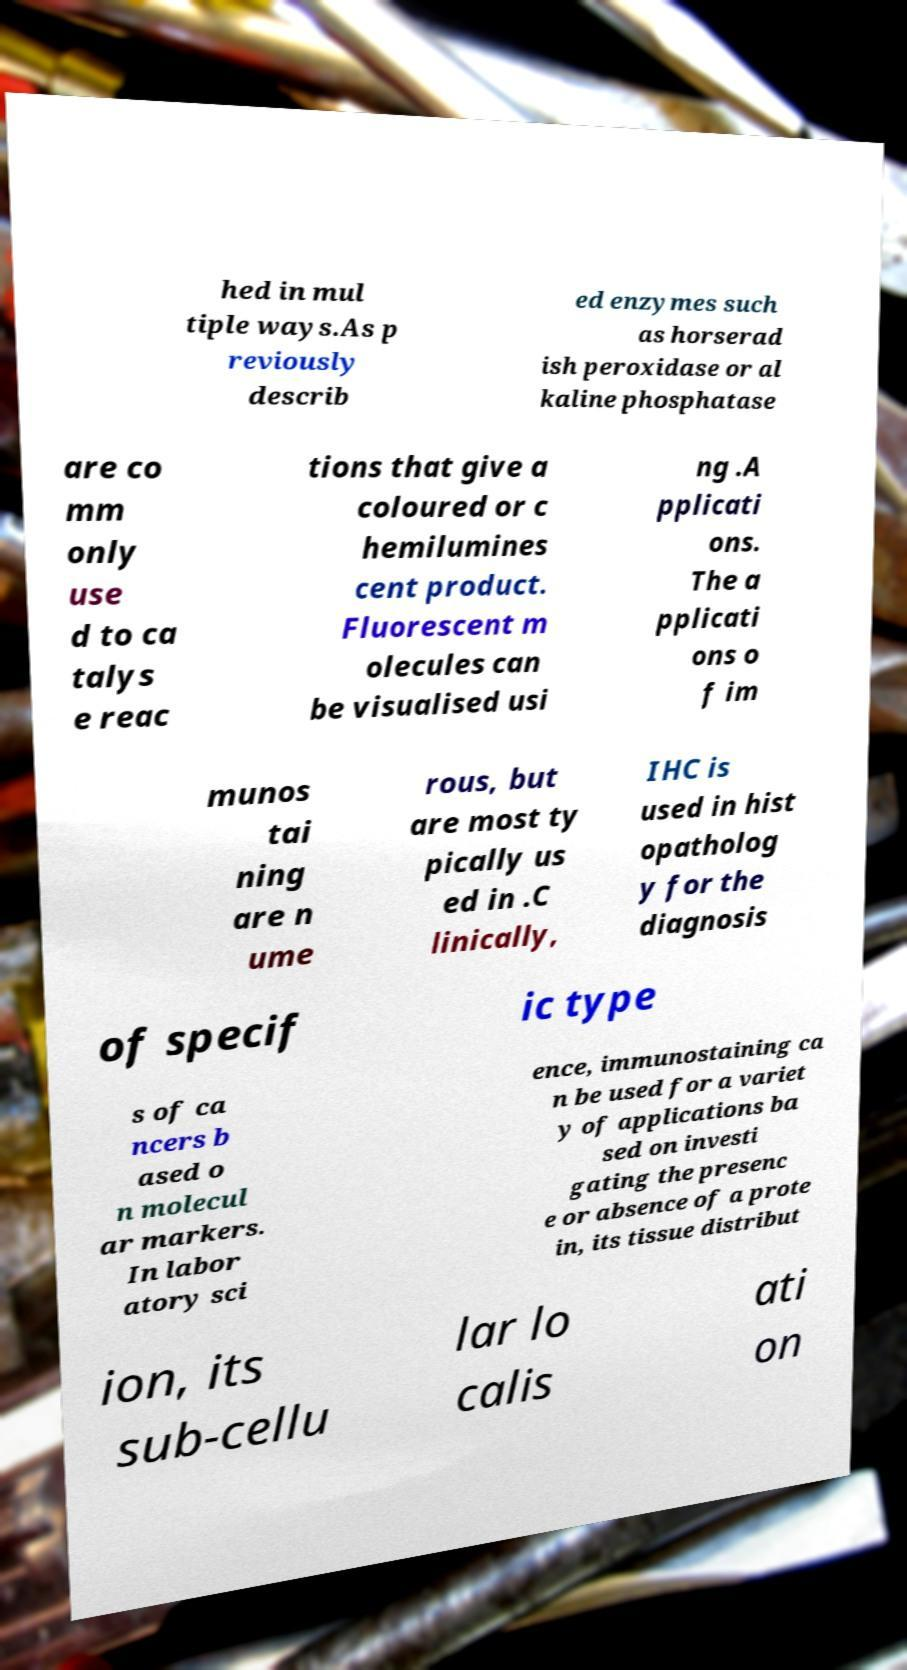Can you accurately transcribe the text from the provided image for me? hed in mul tiple ways.As p reviously describ ed enzymes such as horserad ish peroxidase or al kaline phosphatase are co mm only use d to ca talys e reac tions that give a coloured or c hemilumines cent product. Fluorescent m olecules can be visualised usi ng .A pplicati ons. The a pplicati ons o f im munos tai ning are n ume rous, but are most ty pically us ed in .C linically, IHC is used in hist opatholog y for the diagnosis of specif ic type s of ca ncers b ased o n molecul ar markers. In labor atory sci ence, immunostaining ca n be used for a variet y of applications ba sed on investi gating the presenc e or absence of a prote in, its tissue distribut ion, its sub-cellu lar lo calis ati on 